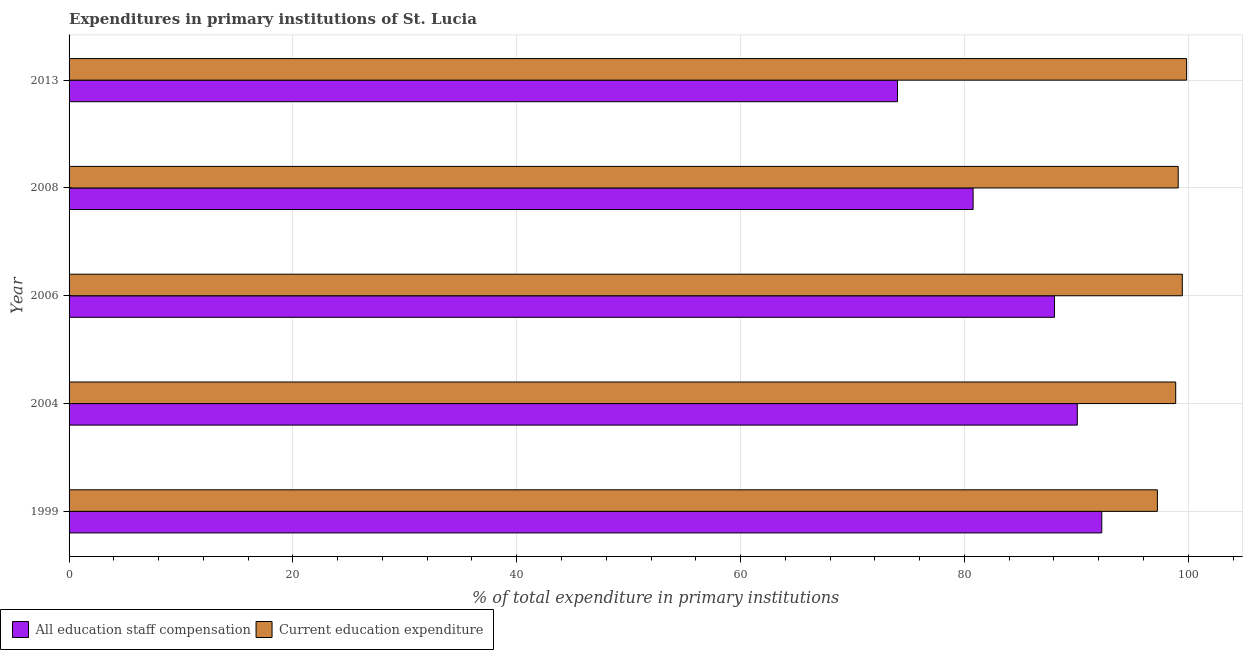How many different coloured bars are there?
Give a very brief answer. 2. Are the number of bars per tick equal to the number of legend labels?
Your answer should be very brief. Yes. Are the number of bars on each tick of the Y-axis equal?
Ensure brevity in your answer.  Yes. How many bars are there on the 5th tick from the top?
Your answer should be compact. 2. In how many cases, is the number of bars for a given year not equal to the number of legend labels?
Keep it short and to the point. 0. What is the expenditure in staff compensation in 1999?
Provide a short and direct response. 92.27. Across all years, what is the maximum expenditure in staff compensation?
Make the answer very short. 92.27. Across all years, what is the minimum expenditure in education?
Your response must be concise. 97.24. What is the total expenditure in education in the graph?
Give a very brief answer. 494.55. What is the difference between the expenditure in staff compensation in 2006 and that in 2013?
Provide a succinct answer. 14.03. What is the difference between the expenditure in education in 2008 and the expenditure in staff compensation in 2006?
Keep it short and to the point. 11.05. What is the average expenditure in education per year?
Your response must be concise. 98.91. In the year 2004, what is the difference between the expenditure in education and expenditure in staff compensation?
Your response must be concise. 8.79. In how many years, is the expenditure in staff compensation greater than 52 %?
Your answer should be very brief. 5. What is the ratio of the expenditure in education in 2004 to that in 2008?
Your answer should be very brief. 1. What is the difference between the highest and the second highest expenditure in staff compensation?
Your answer should be compact. 2.19. What is the difference between the highest and the lowest expenditure in staff compensation?
Your answer should be very brief. 18.25. In how many years, is the expenditure in staff compensation greater than the average expenditure in staff compensation taken over all years?
Provide a succinct answer. 3. Is the sum of the expenditure in staff compensation in 1999 and 2006 greater than the maximum expenditure in education across all years?
Provide a succinct answer. Yes. What does the 2nd bar from the top in 2006 represents?
Offer a terse response. All education staff compensation. What does the 1st bar from the bottom in 2004 represents?
Offer a very short reply. All education staff compensation. Are all the bars in the graph horizontal?
Make the answer very short. Yes. How many years are there in the graph?
Your answer should be very brief. 5. How many legend labels are there?
Your response must be concise. 2. What is the title of the graph?
Offer a very short reply. Expenditures in primary institutions of St. Lucia. Does "Savings" appear as one of the legend labels in the graph?
Your answer should be very brief. No. What is the label or title of the X-axis?
Your response must be concise. % of total expenditure in primary institutions. What is the % of total expenditure in primary institutions of All education staff compensation in 1999?
Make the answer very short. 92.27. What is the % of total expenditure in primary institutions of Current education expenditure in 1999?
Give a very brief answer. 97.24. What is the % of total expenditure in primary institutions in All education staff compensation in 2004?
Provide a short and direct response. 90.09. What is the % of total expenditure in primary institutions in Current education expenditure in 2004?
Ensure brevity in your answer.  98.88. What is the % of total expenditure in primary institutions in All education staff compensation in 2006?
Offer a very short reply. 88.05. What is the % of total expenditure in primary institutions in Current education expenditure in 2006?
Your response must be concise. 99.47. What is the % of total expenditure in primary institutions of All education staff compensation in 2008?
Provide a succinct answer. 80.78. What is the % of total expenditure in primary institutions of Current education expenditure in 2008?
Keep it short and to the point. 99.1. What is the % of total expenditure in primary institutions in All education staff compensation in 2013?
Provide a succinct answer. 74.02. What is the % of total expenditure in primary institutions of Current education expenditure in 2013?
Make the answer very short. 99.85. Across all years, what is the maximum % of total expenditure in primary institutions of All education staff compensation?
Make the answer very short. 92.27. Across all years, what is the maximum % of total expenditure in primary institutions of Current education expenditure?
Offer a very short reply. 99.85. Across all years, what is the minimum % of total expenditure in primary institutions of All education staff compensation?
Provide a short and direct response. 74.02. Across all years, what is the minimum % of total expenditure in primary institutions of Current education expenditure?
Your answer should be very brief. 97.24. What is the total % of total expenditure in primary institutions in All education staff compensation in the graph?
Offer a very short reply. 425.21. What is the total % of total expenditure in primary institutions in Current education expenditure in the graph?
Give a very brief answer. 494.55. What is the difference between the % of total expenditure in primary institutions of All education staff compensation in 1999 and that in 2004?
Keep it short and to the point. 2.19. What is the difference between the % of total expenditure in primary institutions of Current education expenditure in 1999 and that in 2004?
Provide a short and direct response. -1.64. What is the difference between the % of total expenditure in primary institutions in All education staff compensation in 1999 and that in 2006?
Make the answer very short. 4.22. What is the difference between the % of total expenditure in primary institutions in Current education expenditure in 1999 and that in 2006?
Provide a succinct answer. -2.23. What is the difference between the % of total expenditure in primary institutions in All education staff compensation in 1999 and that in 2008?
Provide a succinct answer. 11.5. What is the difference between the % of total expenditure in primary institutions of Current education expenditure in 1999 and that in 2008?
Your answer should be compact. -1.86. What is the difference between the % of total expenditure in primary institutions in All education staff compensation in 1999 and that in 2013?
Offer a terse response. 18.25. What is the difference between the % of total expenditure in primary institutions in Current education expenditure in 1999 and that in 2013?
Give a very brief answer. -2.61. What is the difference between the % of total expenditure in primary institutions of All education staff compensation in 2004 and that in 2006?
Keep it short and to the point. 2.04. What is the difference between the % of total expenditure in primary institutions of Current education expenditure in 2004 and that in 2006?
Offer a very short reply. -0.59. What is the difference between the % of total expenditure in primary institutions in All education staff compensation in 2004 and that in 2008?
Your response must be concise. 9.31. What is the difference between the % of total expenditure in primary institutions in Current education expenditure in 2004 and that in 2008?
Offer a very short reply. -0.22. What is the difference between the % of total expenditure in primary institutions in All education staff compensation in 2004 and that in 2013?
Make the answer very short. 16.07. What is the difference between the % of total expenditure in primary institutions in Current education expenditure in 2004 and that in 2013?
Your answer should be very brief. -0.98. What is the difference between the % of total expenditure in primary institutions of All education staff compensation in 2006 and that in 2008?
Offer a very short reply. 7.27. What is the difference between the % of total expenditure in primary institutions in Current education expenditure in 2006 and that in 2008?
Make the answer very short. 0.37. What is the difference between the % of total expenditure in primary institutions in All education staff compensation in 2006 and that in 2013?
Offer a terse response. 14.03. What is the difference between the % of total expenditure in primary institutions of Current education expenditure in 2006 and that in 2013?
Give a very brief answer. -0.39. What is the difference between the % of total expenditure in primary institutions of All education staff compensation in 2008 and that in 2013?
Offer a terse response. 6.76. What is the difference between the % of total expenditure in primary institutions of Current education expenditure in 2008 and that in 2013?
Your answer should be compact. -0.75. What is the difference between the % of total expenditure in primary institutions of All education staff compensation in 1999 and the % of total expenditure in primary institutions of Current education expenditure in 2004?
Your answer should be compact. -6.61. What is the difference between the % of total expenditure in primary institutions in All education staff compensation in 1999 and the % of total expenditure in primary institutions in Current education expenditure in 2006?
Provide a succinct answer. -7.2. What is the difference between the % of total expenditure in primary institutions of All education staff compensation in 1999 and the % of total expenditure in primary institutions of Current education expenditure in 2008?
Your answer should be compact. -6.83. What is the difference between the % of total expenditure in primary institutions of All education staff compensation in 1999 and the % of total expenditure in primary institutions of Current education expenditure in 2013?
Give a very brief answer. -7.58. What is the difference between the % of total expenditure in primary institutions in All education staff compensation in 2004 and the % of total expenditure in primary institutions in Current education expenditure in 2006?
Provide a short and direct response. -9.38. What is the difference between the % of total expenditure in primary institutions in All education staff compensation in 2004 and the % of total expenditure in primary institutions in Current education expenditure in 2008?
Make the answer very short. -9.01. What is the difference between the % of total expenditure in primary institutions of All education staff compensation in 2004 and the % of total expenditure in primary institutions of Current education expenditure in 2013?
Your answer should be compact. -9.77. What is the difference between the % of total expenditure in primary institutions of All education staff compensation in 2006 and the % of total expenditure in primary institutions of Current education expenditure in 2008?
Provide a succinct answer. -11.05. What is the difference between the % of total expenditure in primary institutions of All education staff compensation in 2006 and the % of total expenditure in primary institutions of Current education expenditure in 2013?
Offer a very short reply. -11.8. What is the difference between the % of total expenditure in primary institutions of All education staff compensation in 2008 and the % of total expenditure in primary institutions of Current education expenditure in 2013?
Your response must be concise. -19.08. What is the average % of total expenditure in primary institutions of All education staff compensation per year?
Your answer should be very brief. 85.04. What is the average % of total expenditure in primary institutions of Current education expenditure per year?
Offer a very short reply. 98.91. In the year 1999, what is the difference between the % of total expenditure in primary institutions in All education staff compensation and % of total expenditure in primary institutions in Current education expenditure?
Offer a terse response. -4.97. In the year 2004, what is the difference between the % of total expenditure in primary institutions in All education staff compensation and % of total expenditure in primary institutions in Current education expenditure?
Your answer should be compact. -8.79. In the year 2006, what is the difference between the % of total expenditure in primary institutions of All education staff compensation and % of total expenditure in primary institutions of Current education expenditure?
Ensure brevity in your answer.  -11.42. In the year 2008, what is the difference between the % of total expenditure in primary institutions in All education staff compensation and % of total expenditure in primary institutions in Current education expenditure?
Keep it short and to the point. -18.33. In the year 2013, what is the difference between the % of total expenditure in primary institutions of All education staff compensation and % of total expenditure in primary institutions of Current education expenditure?
Offer a very short reply. -25.83. What is the ratio of the % of total expenditure in primary institutions of All education staff compensation in 1999 to that in 2004?
Your answer should be very brief. 1.02. What is the ratio of the % of total expenditure in primary institutions in Current education expenditure in 1999 to that in 2004?
Your answer should be compact. 0.98. What is the ratio of the % of total expenditure in primary institutions of All education staff compensation in 1999 to that in 2006?
Provide a short and direct response. 1.05. What is the ratio of the % of total expenditure in primary institutions of Current education expenditure in 1999 to that in 2006?
Ensure brevity in your answer.  0.98. What is the ratio of the % of total expenditure in primary institutions in All education staff compensation in 1999 to that in 2008?
Provide a short and direct response. 1.14. What is the ratio of the % of total expenditure in primary institutions in Current education expenditure in 1999 to that in 2008?
Your answer should be very brief. 0.98. What is the ratio of the % of total expenditure in primary institutions in All education staff compensation in 1999 to that in 2013?
Your answer should be very brief. 1.25. What is the ratio of the % of total expenditure in primary institutions in Current education expenditure in 1999 to that in 2013?
Offer a terse response. 0.97. What is the ratio of the % of total expenditure in primary institutions of All education staff compensation in 2004 to that in 2006?
Offer a very short reply. 1.02. What is the ratio of the % of total expenditure in primary institutions of Current education expenditure in 2004 to that in 2006?
Give a very brief answer. 0.99. What is the ratio of the % of total expenditure in primary institutions of All education staff compensation in 2004 to that in 2008?
Your response must be concise. 1.12. What is the ratio of the % of total expenditure in primary institutions of All education staff compensation in 2004 to that in 2013?
Your answer should be compact. 1.22. What is the ratio of the % of total expenditure in primary institutions of Current education expenditure in 2004 to that in 2013?
Provide a succinct answer. 0.99. What is the ratio of the % of total expenditure in primary institutions in All education staff compensation in 2006 to that in 2008?
Give a very brief answer. 1.09. What is the ratio of the % of total expenditure in primary institutions in Current education expenditure in 2006 to that in 2008?
Provide a short and direct response. 1. What is the ratio of the % of total expenditure in primary institutions of All education staff compensation in 2006 to that in 2013?
Ensure brevity in your answer.  1.19. What is the ratio of the % of total expenditure in primary institutions in Current education expenditure in 2006 to that in 2013?
Provide a short and direct response. 1. What is the ratio of the % of total expenditure in primary institutions of All education staff compensation in 2008 to that in 2013?
Your answer should be very brief. 1.09. What is the ratio of the % of total expenditure in primary institutions of Current education expenditure in 2008 to that in 2013?
Your answer should be compact. 0.99. What is the difference between the highest and the second highest % of total expenditure in primary institutions in All education staff compensation?
Your answer should be compact. 2.19. What is the difference between the highest and the second highest % of total expenditure in primary institutions in Current education expenditure?
Ensure brevity in your answer.  0.39. What is the difference between the highest and the lowest % of total expenditure in primary institutions of All education staff compensation?
Your response must be concise. 18.25. What is the difference between the highest and the lowest % of total expenditure in primary institutions in Current education expenditure?
Your answer should be compact. 2.61. 